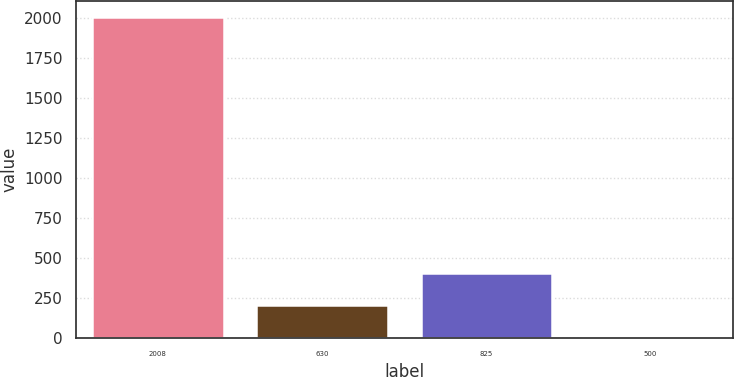Convert chart to OTSL. <chart><loc_0><loc_0><loc_500><loc_500><bar_chart><fcel>2008<fcel>630<fcel>825<fcel>500<nl><fcel>2008<fcel>205.3<fcel>405.6<fcel>5<nl></chart> 